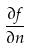Convert formula to latex. <formula><loc_0><loc_0><loc_500><loc_500>\frac { \partial f } { \partial n }</formula> 